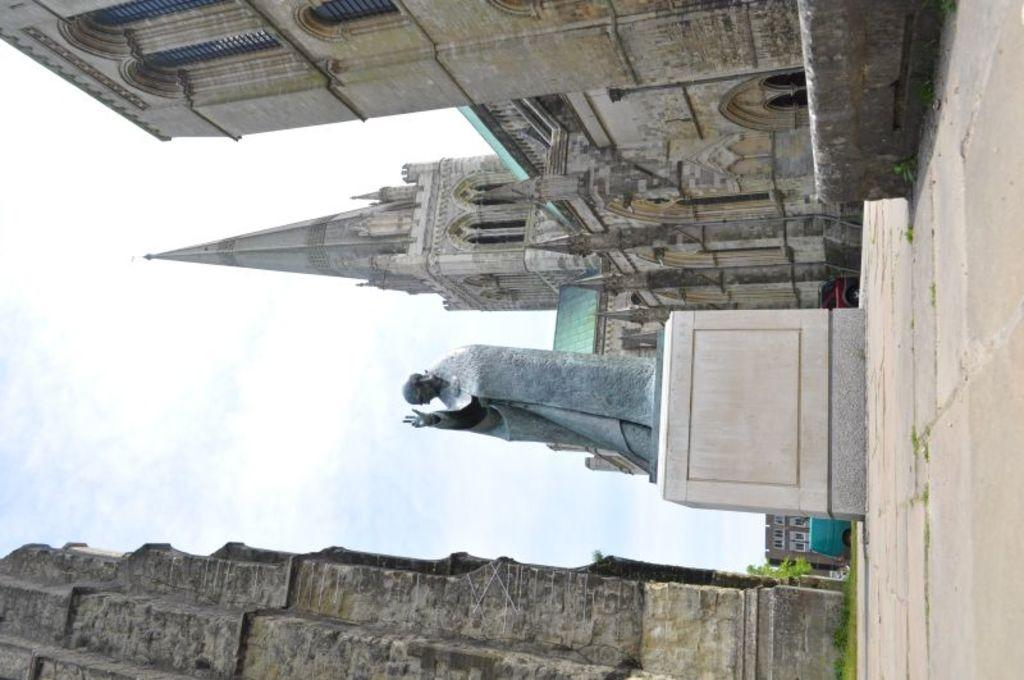What is the main subject in the image? There is a statue in the image. What other structures can be seen in the image? There is a tower and buildings on either side of the statue. What is visible in the background of the image? The sky is visible in the background of the image. What type of cake is being served at the base of the statue in the image? There is no cake present in the image; it features a statue, a tower, and buildings. What is the statue using to support itself in the image? The statue does not require support in the image; it is standing on its own. 